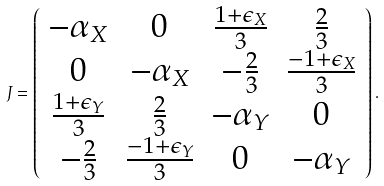Convert formula to latex. <formula><loc_0><loc_0><loc_500><loc_500>J = \left ( \begin{array} { c c c c } - \alpha _ { X } & 0 & \frac { 1 + \epsilon _ { X } } 3 & \frac { 2 } { 3 } \\ 0 & - \alpha _ { X } & - \frac { 2 } { 3 } & \frac { - 1 + \epsilon _ { X } } { 3 } \\ \frac { 1 + \epsilon _ { Y } } { 3 } & \frac { 2 } { 3 } & - \alpha _ { Y } & 0 \\ - \frac { 2 } { 3 } & \frac { - 1 + \epsilon _ { Y } } { 3 } & 0 & - \alpha _ { Y } \\ \end{array} \right ) .</formula> 